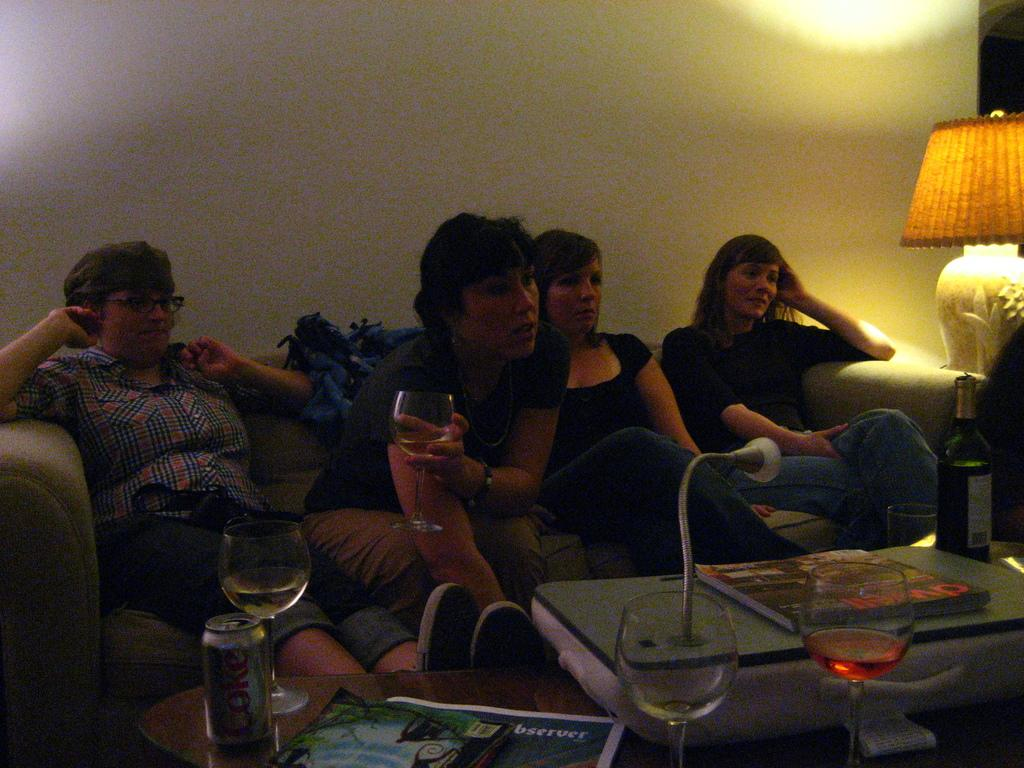What can be seen in the background of the image? There is a wall in the background of the image. What are the persons in the image doing? The persons are sitting on a sofa side by side. What type of lighting is present in the image? There is a lamp in the image. What objects are on the table in the image? There is a tin, drinking glasses, a paper, and a book on the table. How many hooks are visible in the image? There are no hooks present in the image. What type of shake is being prepared on the table? There is no shake being prepared or present in the image; there are only a tin, drinking glasses, a paper, and a book on the table. 